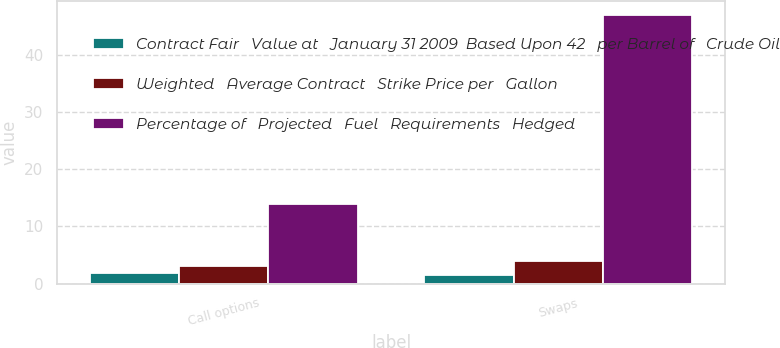Convert chart to OTSL. <chart><loc_0><loc_0><loc_500><loc_500><stacked_bar_chart><ecel><fcel>Call options<fcel>Swaps<nl><fcel>Contract Fair   Value at   January 31 2009  Based Upon 42   per Barrel of   Crude Oil<fcel>1.9<fcel>1.58<nl><fcel>Weighted   Average Contract   Strike Price per   Gallon<fcel>3<fcel>4<nl><fcel>Percentage of   Projected   Fuel   Requirements   Hedged<fcel>14<fcel>47<nl></chart> 